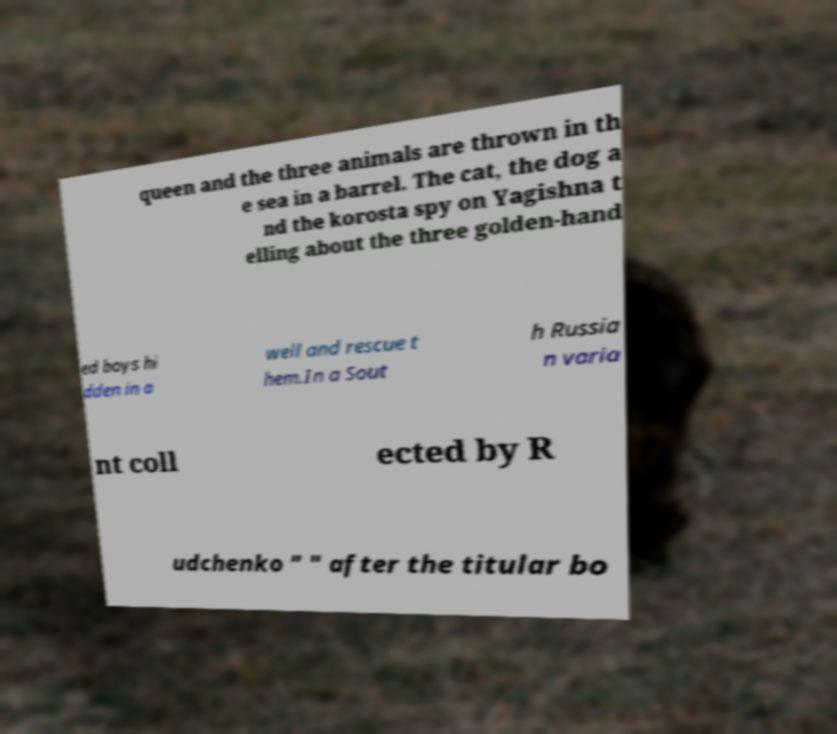Please read and relay the text visible in this image. What does it say? queen and the three animals are thrown in th e sea in a barrel. The cat, the dog a nd the korosta spy on Yagishna t elling about the three golden-hand ed boys hi dden in a well and rescue t hem.In a Sout h Russia n varia nt coll ected by R udchenko " " after the titular bo 